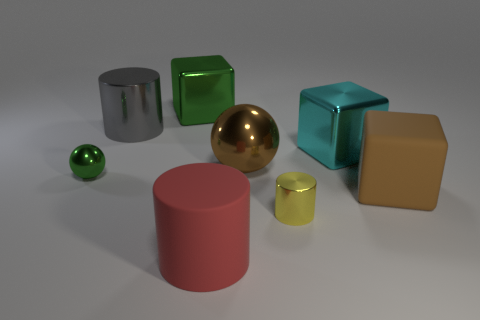Subtract all tiny metallic cylinders. How many cylinders are left? 2 Add 2 big cyan blocks. How many objects exist? 10 Subtract all green cylinders. Subtract all green blocks. How many cylinders are left? 3 Add 8 large green blocks. How many large green blocks are left? 9 Add 5 brown metal things. How many brown metal things exist? 6 Subtract 0 green cylinders. How many objects are left? 8 Subtract all cylinders. How many objects are left? 5 Subtract all large purple objects. Subtract all large rubber cylinders. How many objects are left? 7 